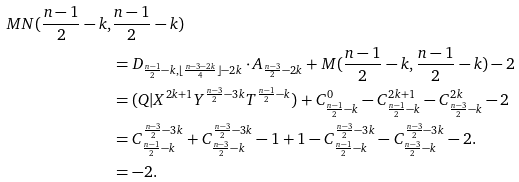Convert formula to latex. <formula><loc_0><loc_0><loc_500><loc_500>M N ( \frac { n - 1 } { 2 } - k , & \frac { n - 1 } { 2 } - k ) \\ & = D _ { \frac { n - 1 } { 2 } - k , \lfloor \frac { n - 3 - 2 k } { 4 } \rfloor - 2 k } \cdot A _ { \frac { n - 3 } { 2 } - 2 k } + M ( \frac { n - 1 } { 2 } - k , \frac { n - 1 } { 2 } - k ) - 2 \\ & = ( Q | X ^ { 2 k + 1 } Y ^ { \frac { n - 3 } { 2 } - 3 k } T ^ { \frac { n - 1 } { 2 } - k } ) + C _ { \frac { n - 1 } { 2 } - k } ^ { 0 } - C _ { \frac { n - 1 } { 2 } - k } ^ { 2 k + 1 } - C _ { \frac { n - 3 } { 2 } - k } ^ { 2 k } - 2 \\ & = C _ { \frac { n - 1 } { 2 } - k } ^ { \frac { n - 3 } { 2 } - 3 k } + C _ { \frac { n - 3 } { 2 } - k } ^ { \frac { n - 3 } { 2 } - 3 k } - 1 + 1 - C _ { \frac { n - 1 } { 2 } - k } ^ { \frac { n - 3 } { 2 } - 3 k } - C _ { \frac { n - 3 } { 2 } - k } ^ { \frac { n - 3 } { 2 } - 3 k } - 2 . \\ & = - 2 .</formula> 